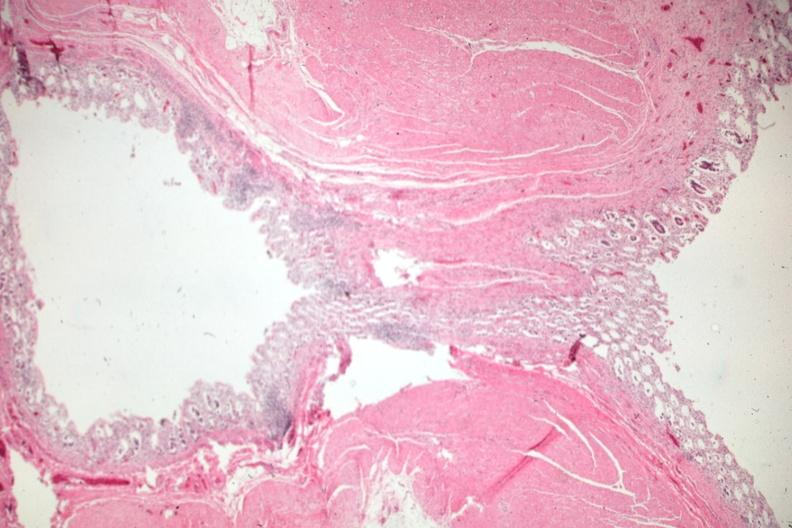what is present?
Answer the question using a single word or phrase. Gastrointestinal 